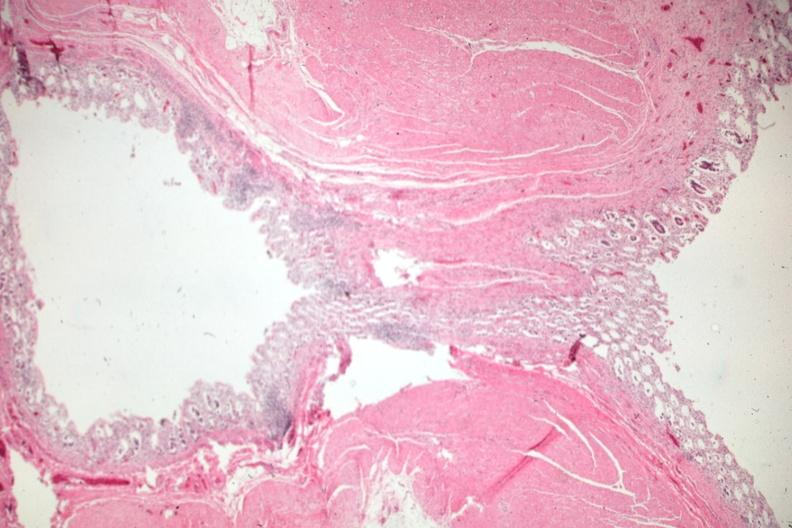what is present?
Answer the question using a single word or phrase. Gastrointestinal 